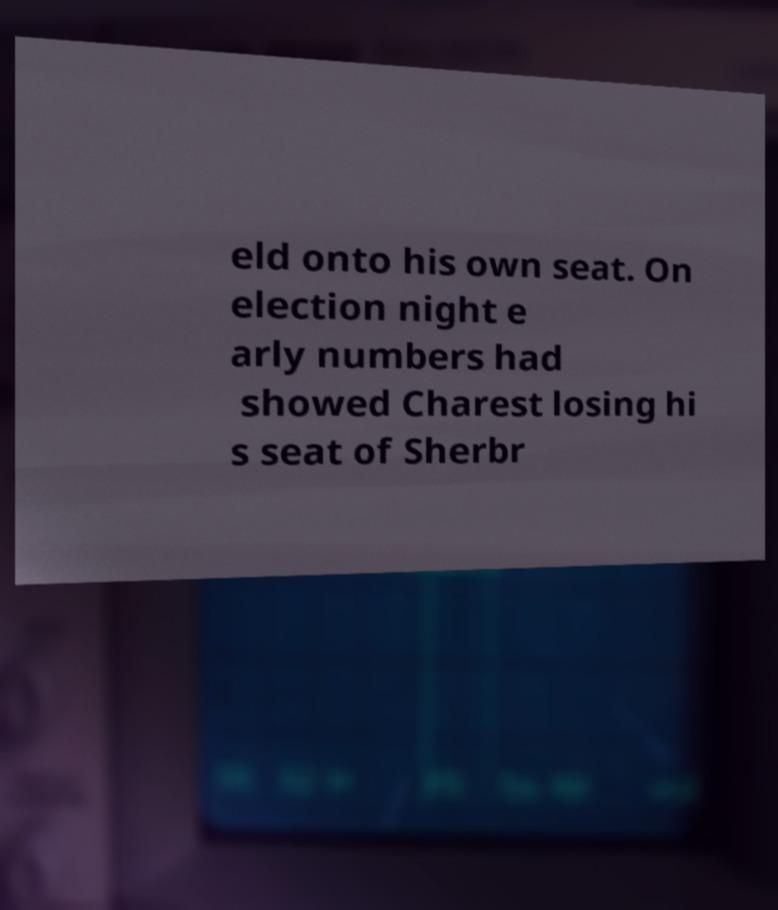For documentation purposes, I need the text within this image transcribed. Could you provide that? eld onto his own seat. On election night e arly numbers had showed Charest losing hi s seat of Sherbr 